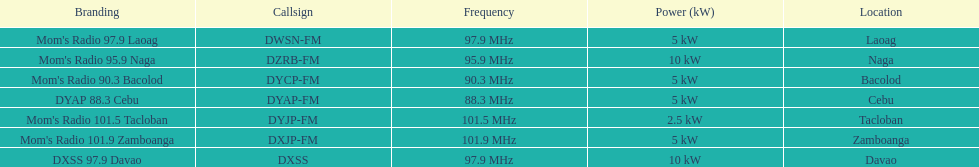What is the single radio station having a frequency less than 90 mhz? DYAP 88.3 Cebu. 